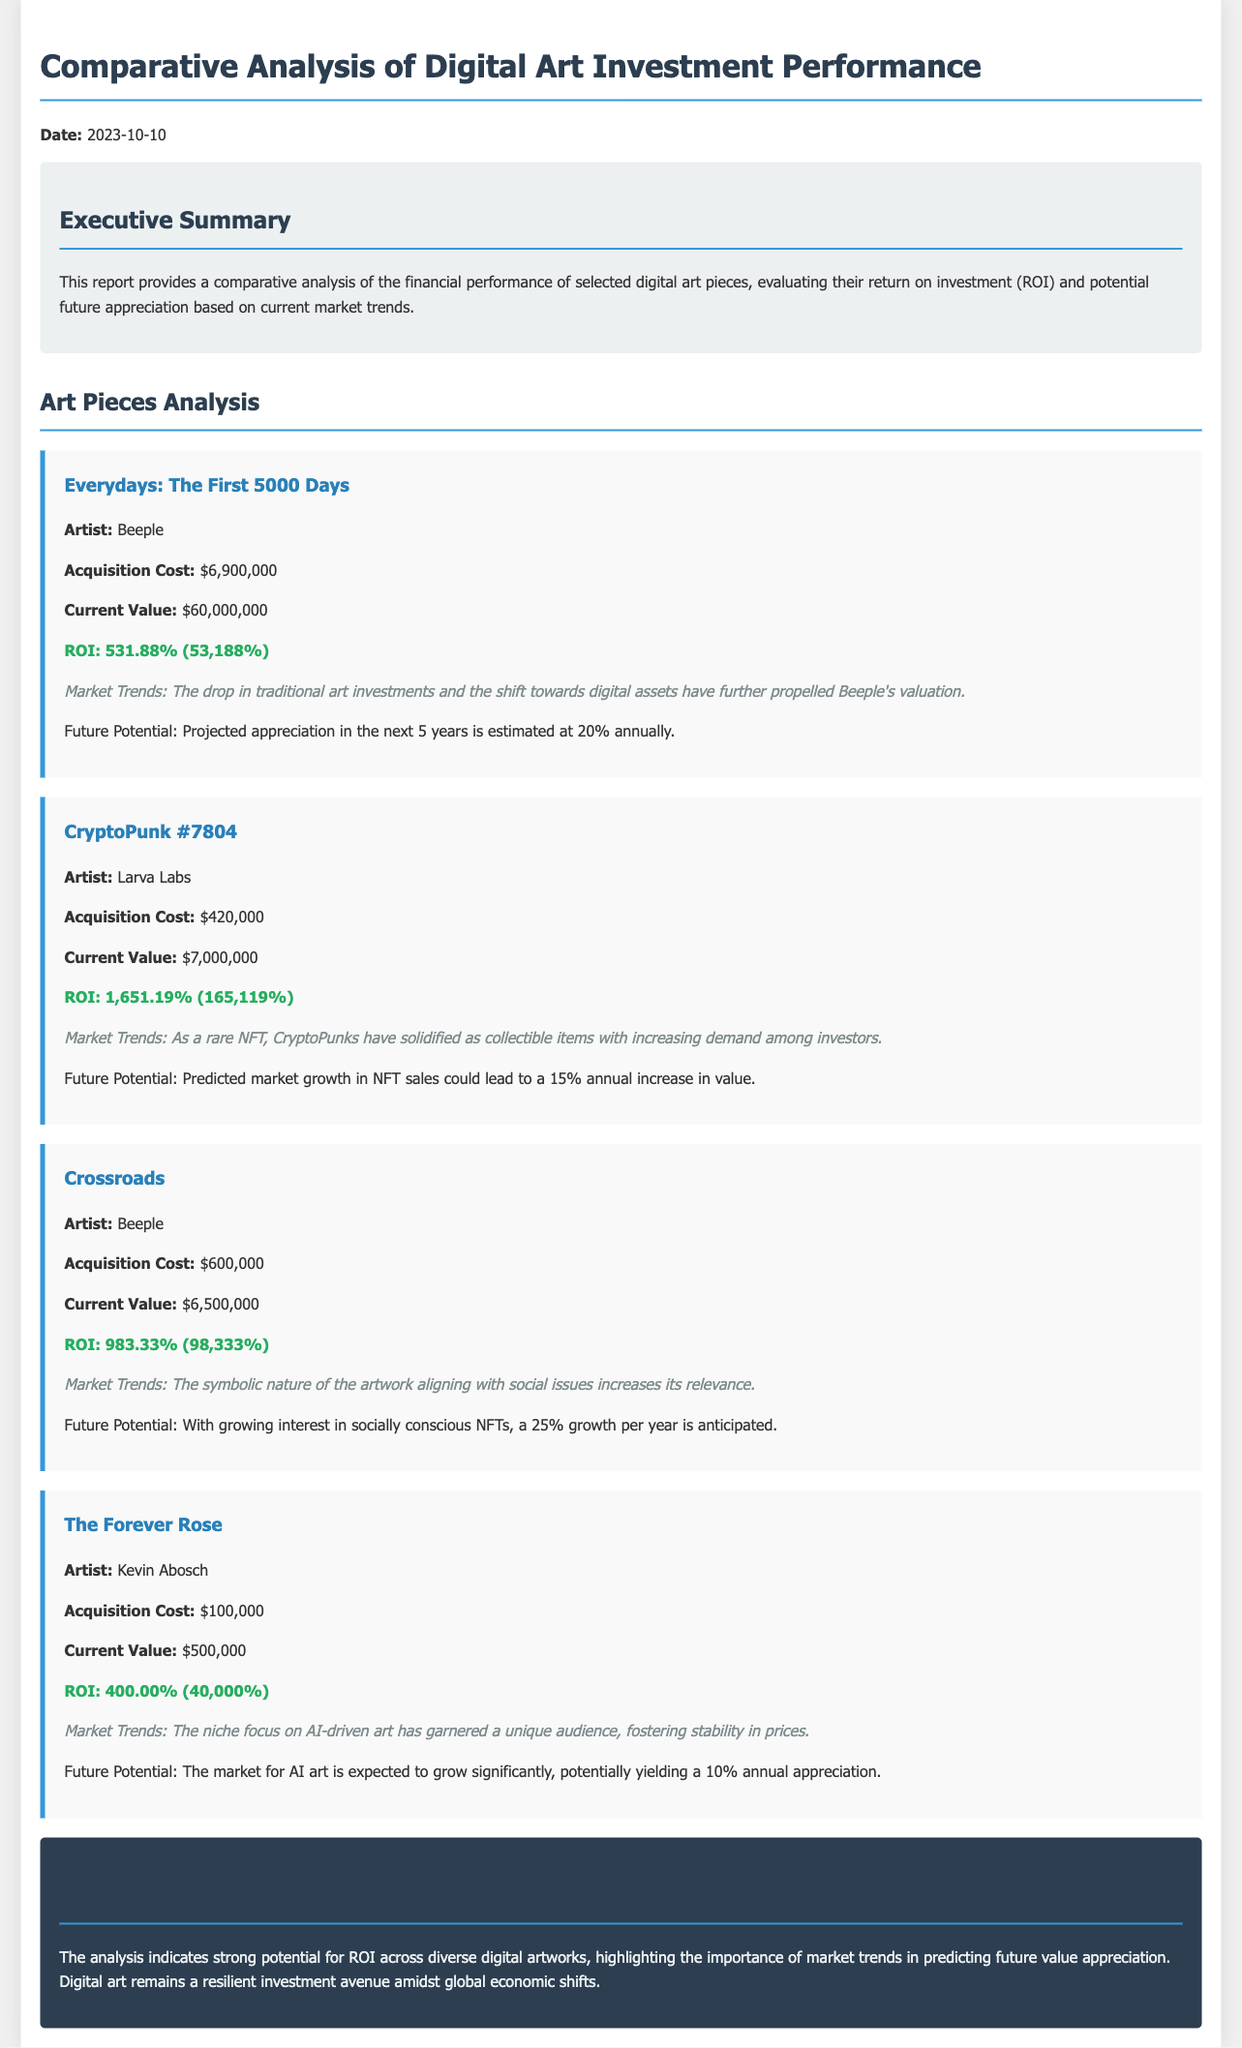What is the acquisition cost of "Everydays: The First 5000 Days"? The acquisition cost is listed in the document for the art piece "Everydays: The First 5000 Days," which is $6,900,000.
Answer: $6,900,000 What is the current value of "CryptoPunk #7804"? The document specifies that the current value of "CryptoPunk #7804" is $7,000,000.
Answer: $7,000,000 What is the ROI percentage for "Crossroads"? The ROI percentage calculated for the art piece "Crossroads" is 983.33%.
Answer: 983.33% Which artist created "The Forever Rose"? The document identifies Kevin Abosch as the artist of "The Forever Rose."
Answer: Kevin Abosch What is the projected annual growth for "Crossroads"? The future potential indicates that "Crossroads" is anticipated to grow at a rate of 25% annually.
Answer: 25% Which art piece has the highest ROI? The document highlights "CryptoPunk #7804" as having the highest ROI calculated at 1,651.19%.
Answer: CryptoPunk #7804 What is the main market trend associated with "Everydays: The First 5000 Days"? It states that the drop in traditional art investments and the shift towards digital assets have propelled Beeple's valuation.
Answer: Shift towards digital assets How many art pieces are analyzed in the report? The report analyzes a total of four distinct digital art pieces.
Answer: Four What is the conclusion regarding digital art investments? The conclusion notes that digital art remains a resilient investment avenue amidst global economic shifts.
Answer: Resilient investment avenue 